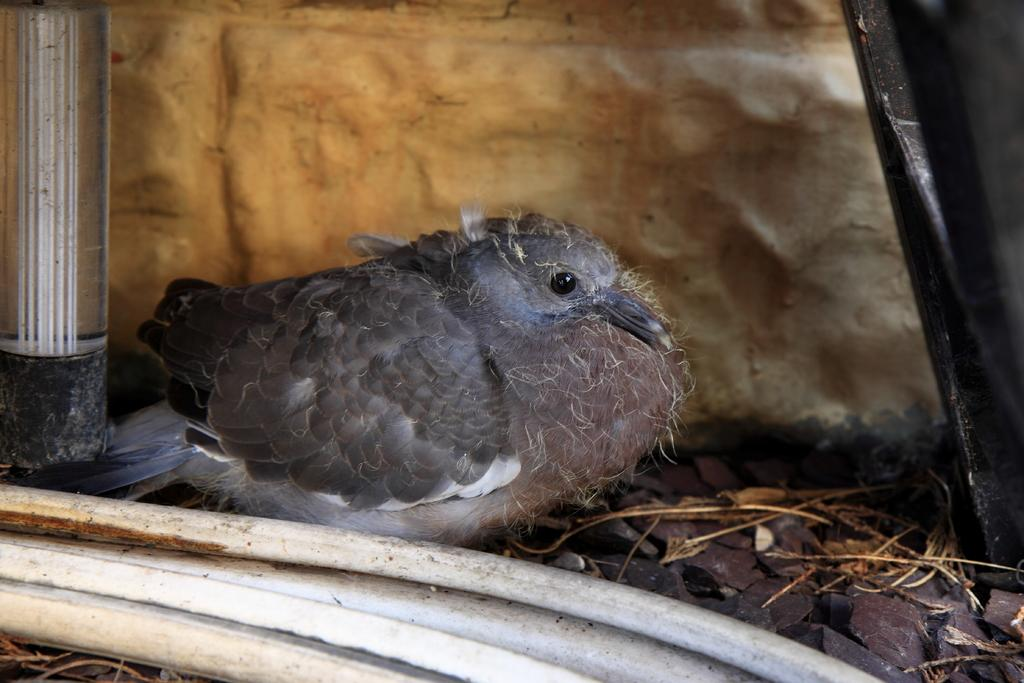What is the main subject in the center of the image? There is a bird in the center of the image. What can be seen at the bottom of the image? There are stones at the bottom of the image. How many birds are in a flock in the image? There is only one bird present in the image, so it cannot be considered a flock. What type of peace symbol can be seen in the image? There is no peace symbol present in the image; it features a bird and stones. 